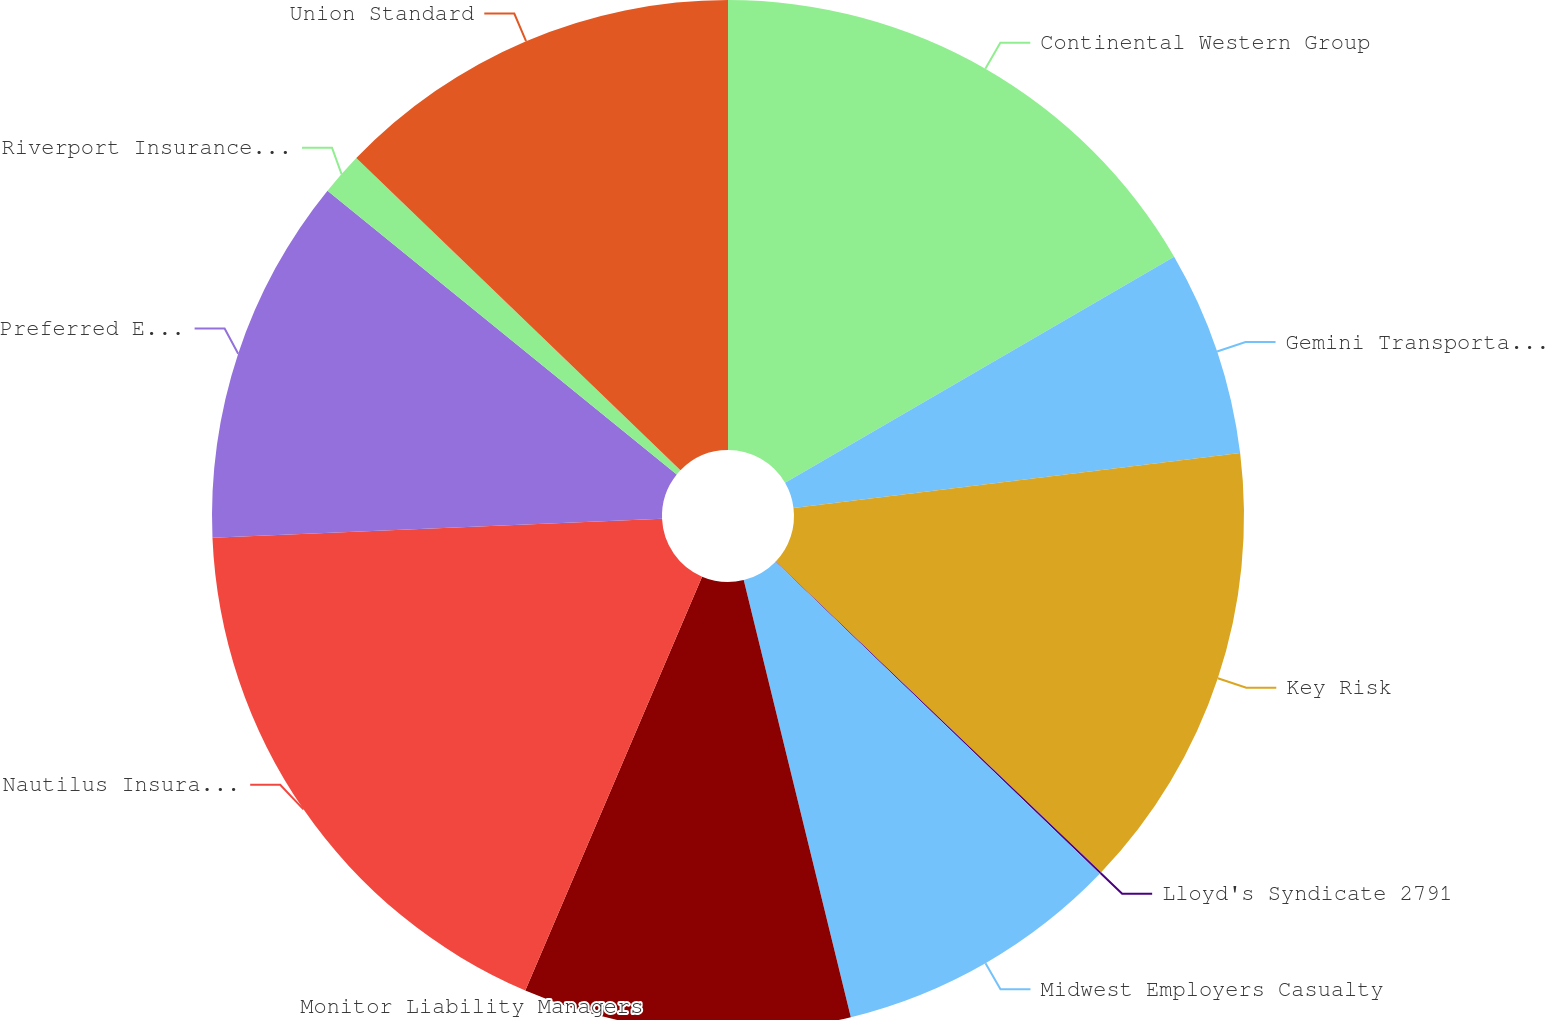Convert chart to OTSL. <chart><loc_0><loc_0><loc_500><loc_500><pie_chart><fcel>Continental Western Group<fcel>Gemini Transportation<fcel>Key Risk<fcel>Lloyd's Syndicate 2791<fcel>Midwest Employers Casualty<fcel>Monitor Liability Managers<fcel>Nautilus Insurance Group<fcel>Preferred Employers Insurance<fcel>Riverport Insurances Services<fcel>Union Standard<nl><fcel>16.62%<fcel>6.43%<fcel>14.08%<fcel>0.06%<fcel>8.98%<fcel>10.25%<fcel>17.9%<fcel>11.53%<fcel>1.34%<fcel>12.8%<nl></chart> 